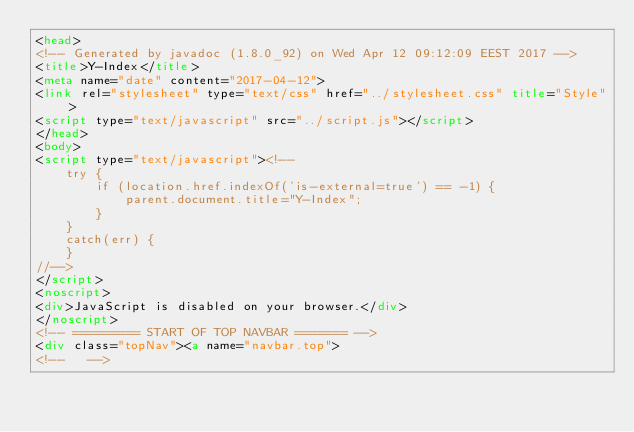<code> <loc_0><loc_0><loc_500><loc_500><_HTML_><head>
<!-- Generated by javadoc (1.8.0_92) on Wed Apr 12 09:12:09 EEST 2017 -->
<title>Y-Index</title>
<meta name="date" content="2017-04-12">
<link rel="stylesheet" type="text/css" href="../stylesheet.css" title="Style">
<script type="text/javascript" src="../script.js"></script>
</head>
<body>
<script type="text/javascript"><!--
    try {
        if (location.href.indexOf('is-external=true') == -1) {
            parent.document.title="Y-Index";
        }
    }
    catch(err) {
    }
//-->
</script>
<noscript>
<div>JavaScript is disabled on your browser.</div>
</noscript>
<!-- ========= START OF TOP NAVBAR ======= -->
<div class="topNav"><a name="navbar.top">
<!--   --></code> 